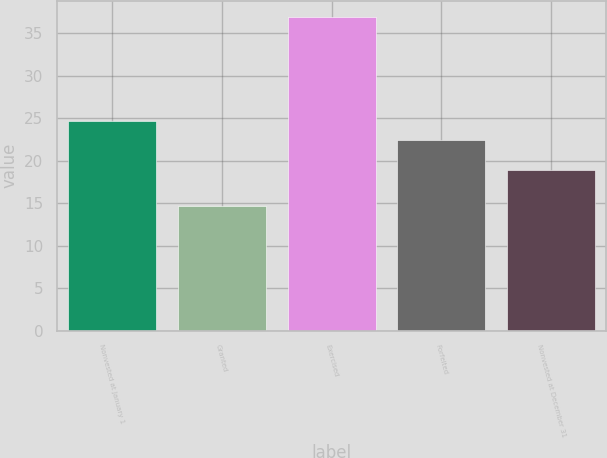<chart> <loc_0><loc_0><loc_500><loc_500><bar_chart><fcel>Nonvested at January 1<fcel>Granted<fcel>Exercised<fcel>Forfeited<fcel>Nonvested at December 31<nl><fcel>24.62<fcel>14.69<fcel>36.96<fcel>22.39<fcel>18.89<nl></chart> 